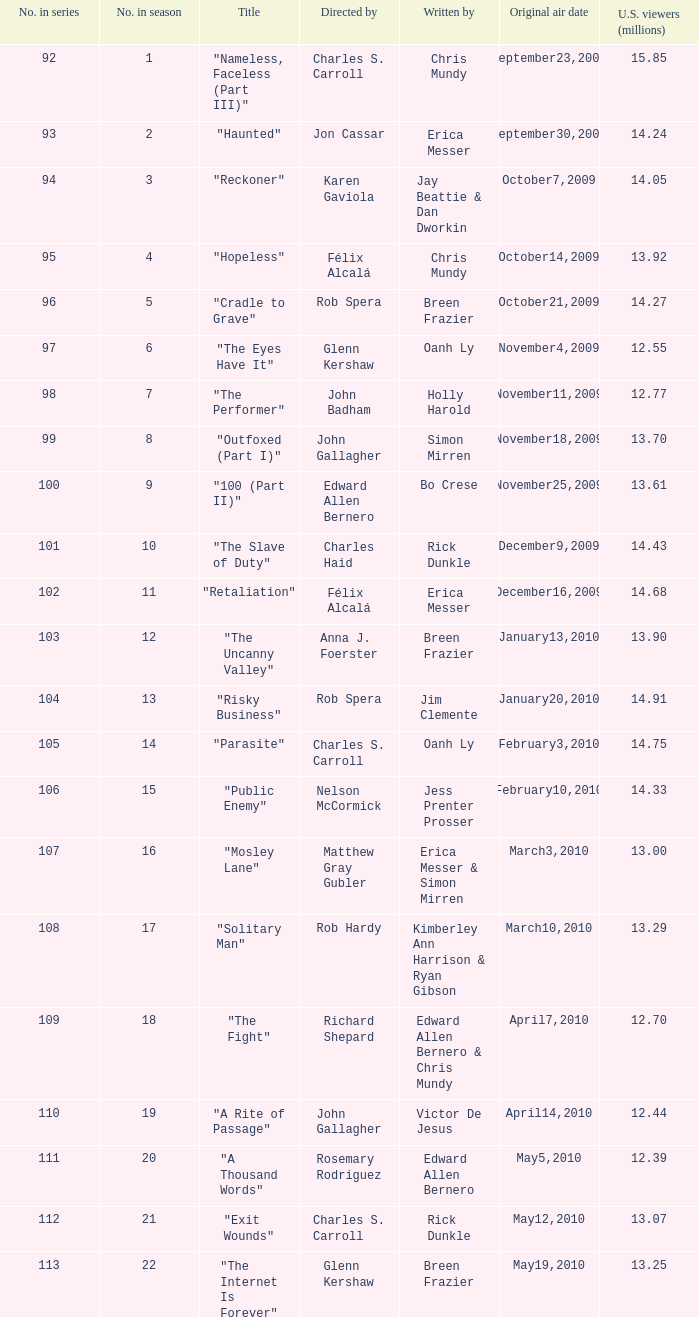92 million us viewers? October14,2009. 